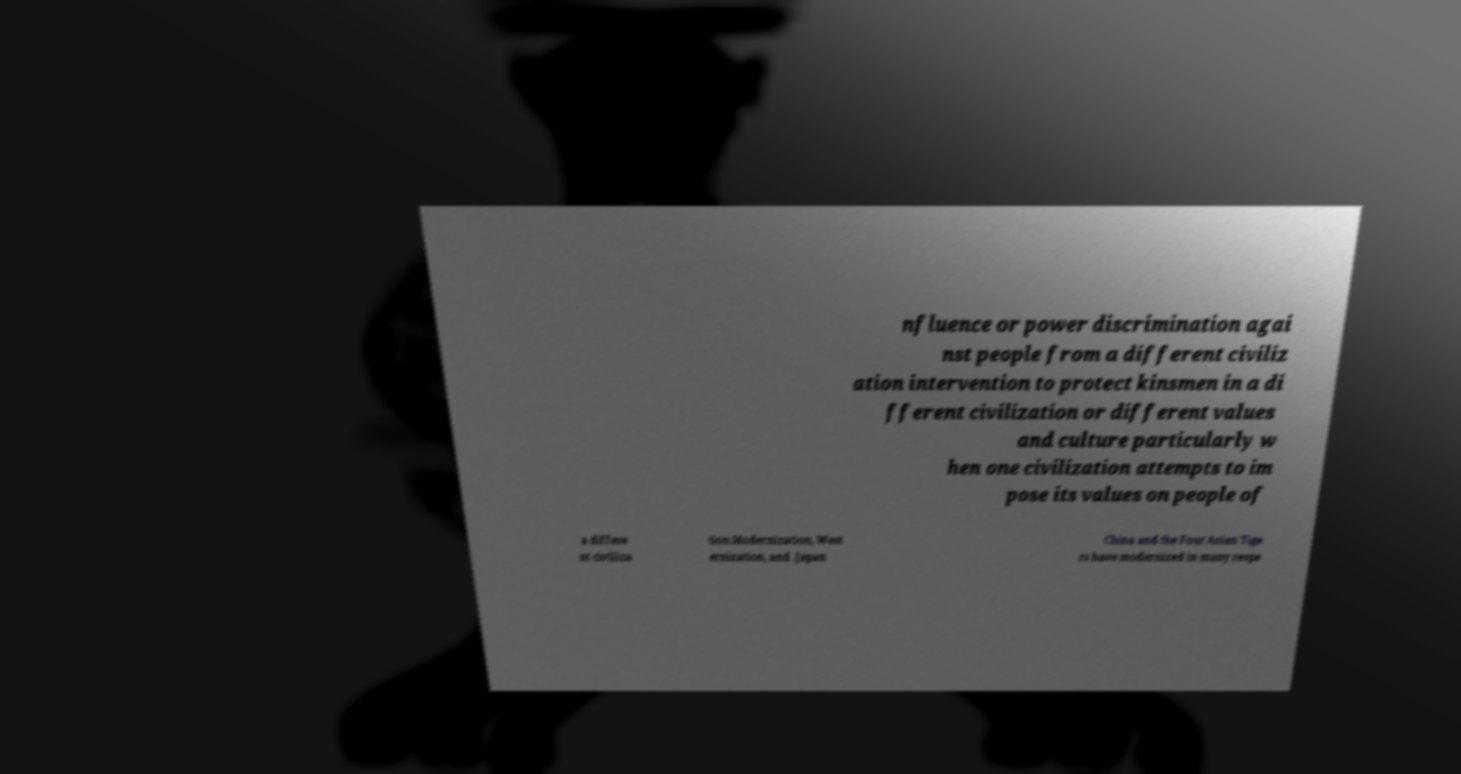Please identify and transcribe the text found in this image. nfluence or power discrimination agai nst people from a different civiliz ation intervention to protect kinsmen in a di fferent civilization or different values and culture particularly w hen one civilization attempts to im pose its values on people of a differe nt civiliza tion.Modernization, West ernization, and .Japan China and the Four Asian Tige rs have modernized in many respe 